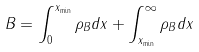<formula> <loc_0><loc_0><loc_500><loc_500>B = \int _ { 0 } ^ { x _ { \min } } \rho _ { B } d x + \int _ { x _ { \min } } ^ { \infty } \rho _ { B } d x</formula> 